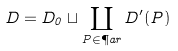Convert formula to latex. <formula><loc_0><loc_0><loc_500><loc_500>D = D _ { 0 } \sqcup \coprod _ { P \in \P a r } D ^ { \prime } ( P )</formula> 